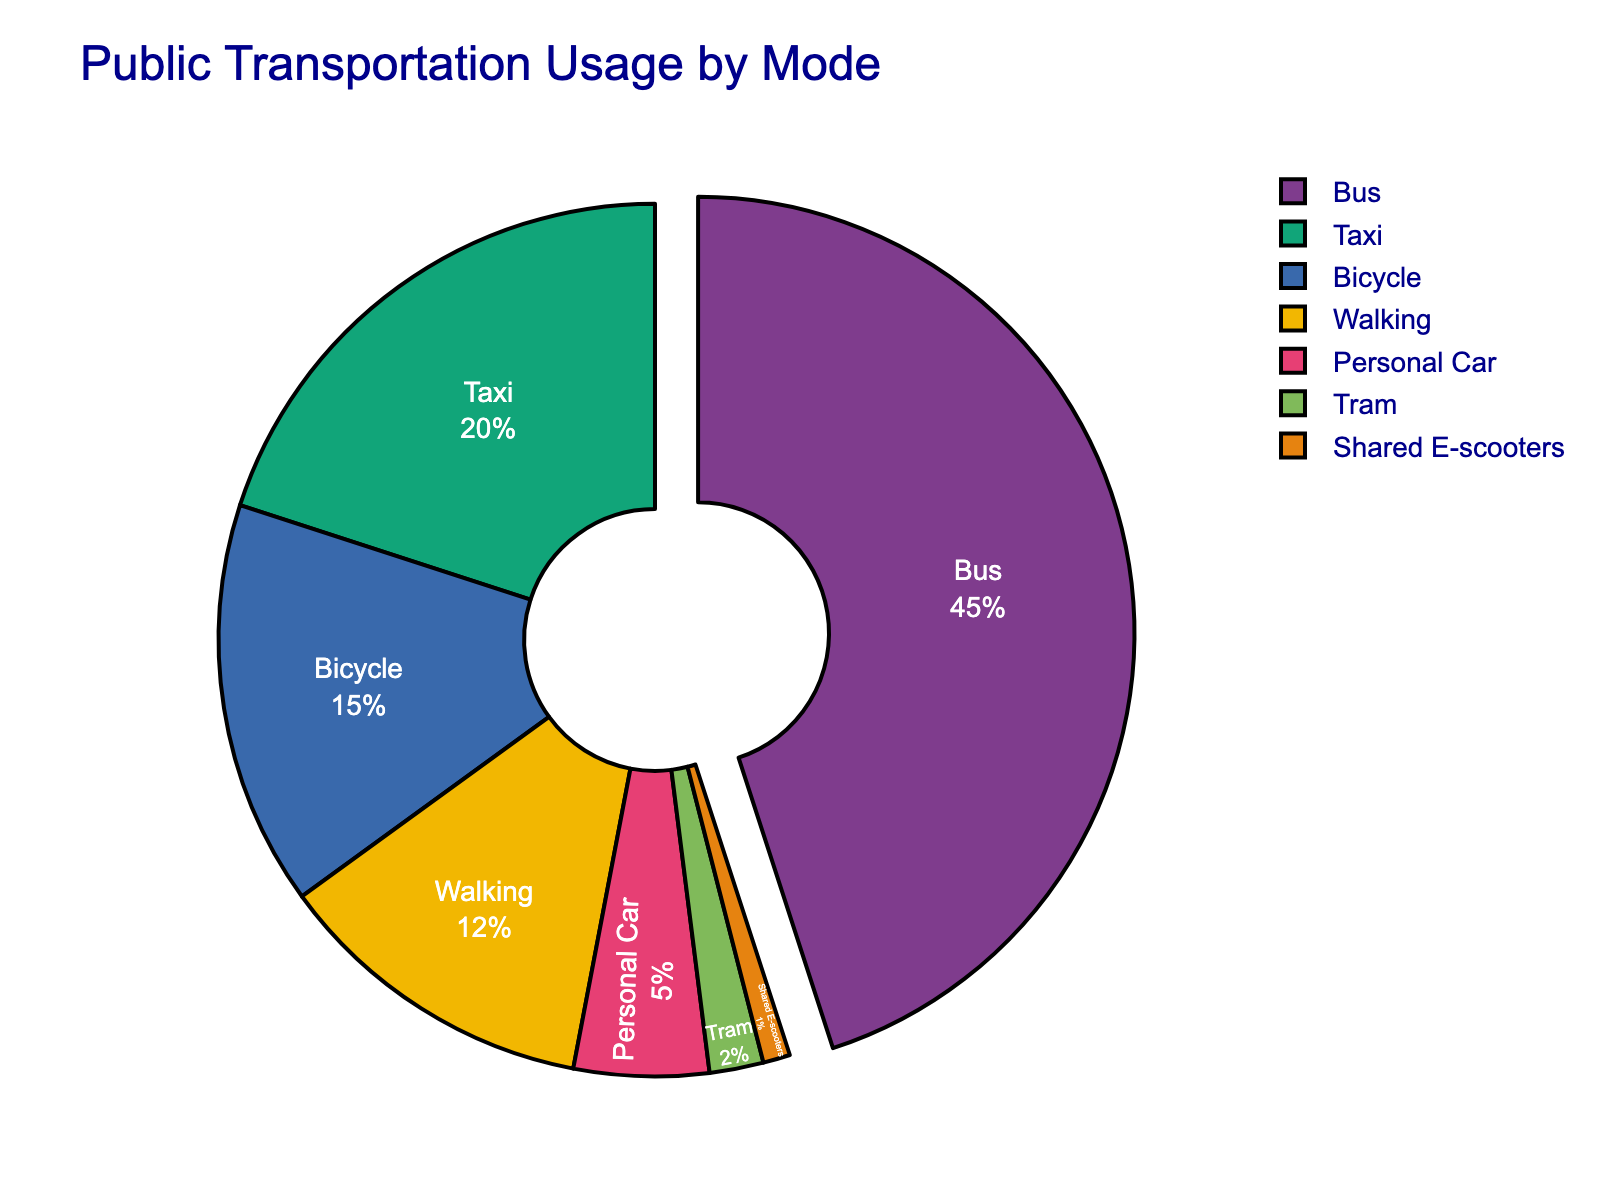What mode of transportation has the highest usage? The largest segment in the pie chart is clearly labeled “Bus” and occupies the largest portion of the chart. Therefore, buses are the most used mode of transportation.
Answer: Bus What is the combined percentage usage of Bicycle and Walking? From the chart, the usage percentage for bicycles is 15% and for walking is 12%. Summing these percentages gives 15% + 12% = 27%.
Answer: 27% Which mode of transportation has a lesser percentage usage than Personal Car but more than Shared E-scooters? From the chart, the percentage usage for Tram is 2%, which is less than the 5% for Personal Car but more than the 1% for Shared E-scooters.
Answer: Tram How much more is the usage of Buses compared to Shared E-scooters in percentage points? Bus usage is 45% while Shared E-scooters usage is 1%. The difference in their usage is 45% - 1% = 44%.
Answer: 44% Which mode of transportation uses the blue color in the pie chart? Visual inspection of the pie chart shows that the segment for “Walking” is colored blue.
Answer: Walking 